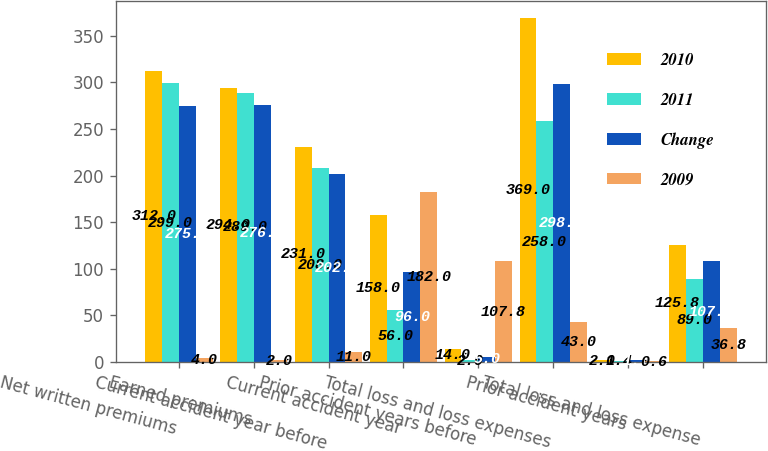Convert chart to OTSL. <chart><loc_0><loc_0><loc_500><loc_500><stacked_bar_chart><ecel><fcel>Net written premiums<fcel>Earned premiums<fcel>Current accident year before<fcel>Current accident year<fcel>Prior accident years before<fcel>Total loss and loss expenses<fcel>Prior accident years<fcel>Total loss and loss expense<nl><fcel>2010<fcel>312<fcel>294<fcel>231<fcel>158<fcel>14<fcel>369<fcel>2<fcel>125.8<nl><fcel>2011<fcel>299<fcel>289<fcel>208<fcel>56<fcel>2<fcel>258<fcel>1.4<fcel>89<nl><fcel>Change<fcel>275<fcel>276<fcel>202<fcel>96<fcel>5<fcel>298<fcel>1.7<fcel>107.8<nl><fcel>2009<fcel>4<fcel>2<fcel>11<fcel>182<fcel>107.8<fcel>43<fcel>0.6<fcel>36.8<nl></chart> 